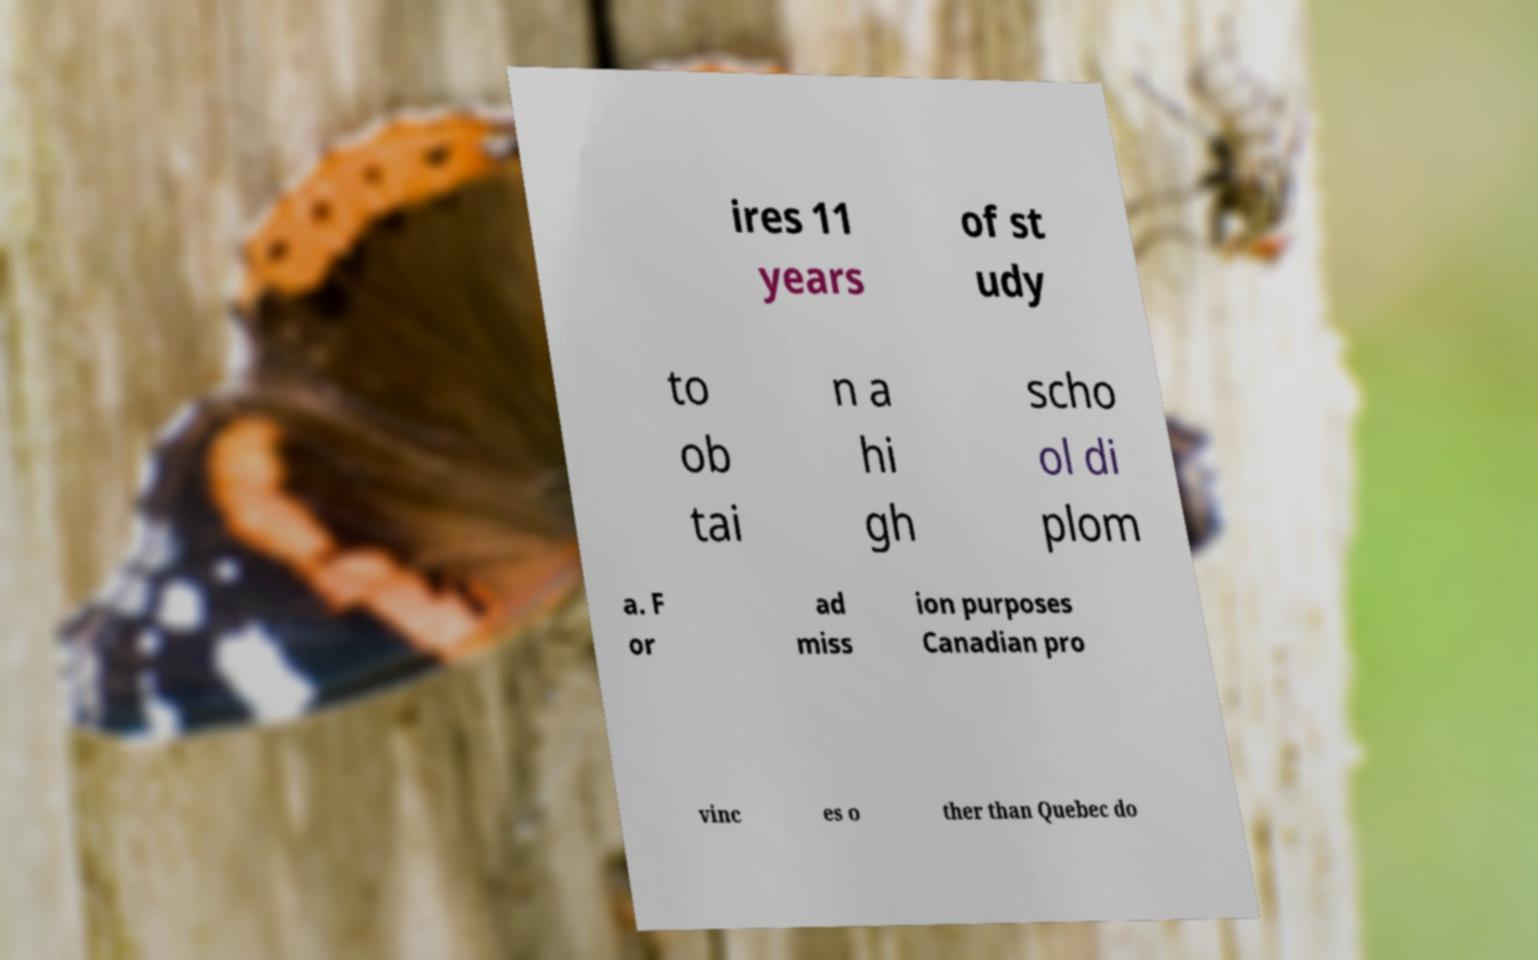For documentation purposes, I need the text within this image transcribed. Could you provide that? ires 11 years of st udy to ob tai n a hi gh scho ol di plom a. F or ad miss ion purposes Canadian pro vinc es o ther than Quebec do 